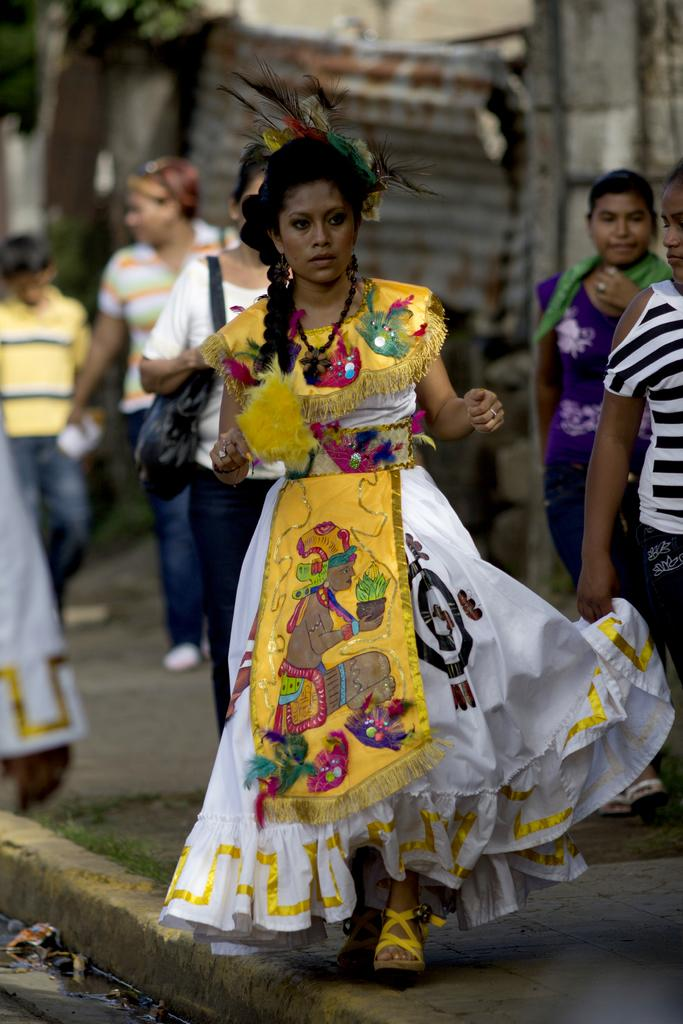What are the people in the image doing? There is a group of people walking in the image. Where are the people walking? The people are walking on a footpath. What can be seen in the background of the image? There is a building and trees in the background of the image. What type of vegetation is visible in the image? There is grass visible in the image. What is the negative aspect present in the image? There is garbage present in the image. What type of smell can be detected from the garbage in the image? The image does not provide any information about the smell of the garbage, so it cannot be determined from the image. 